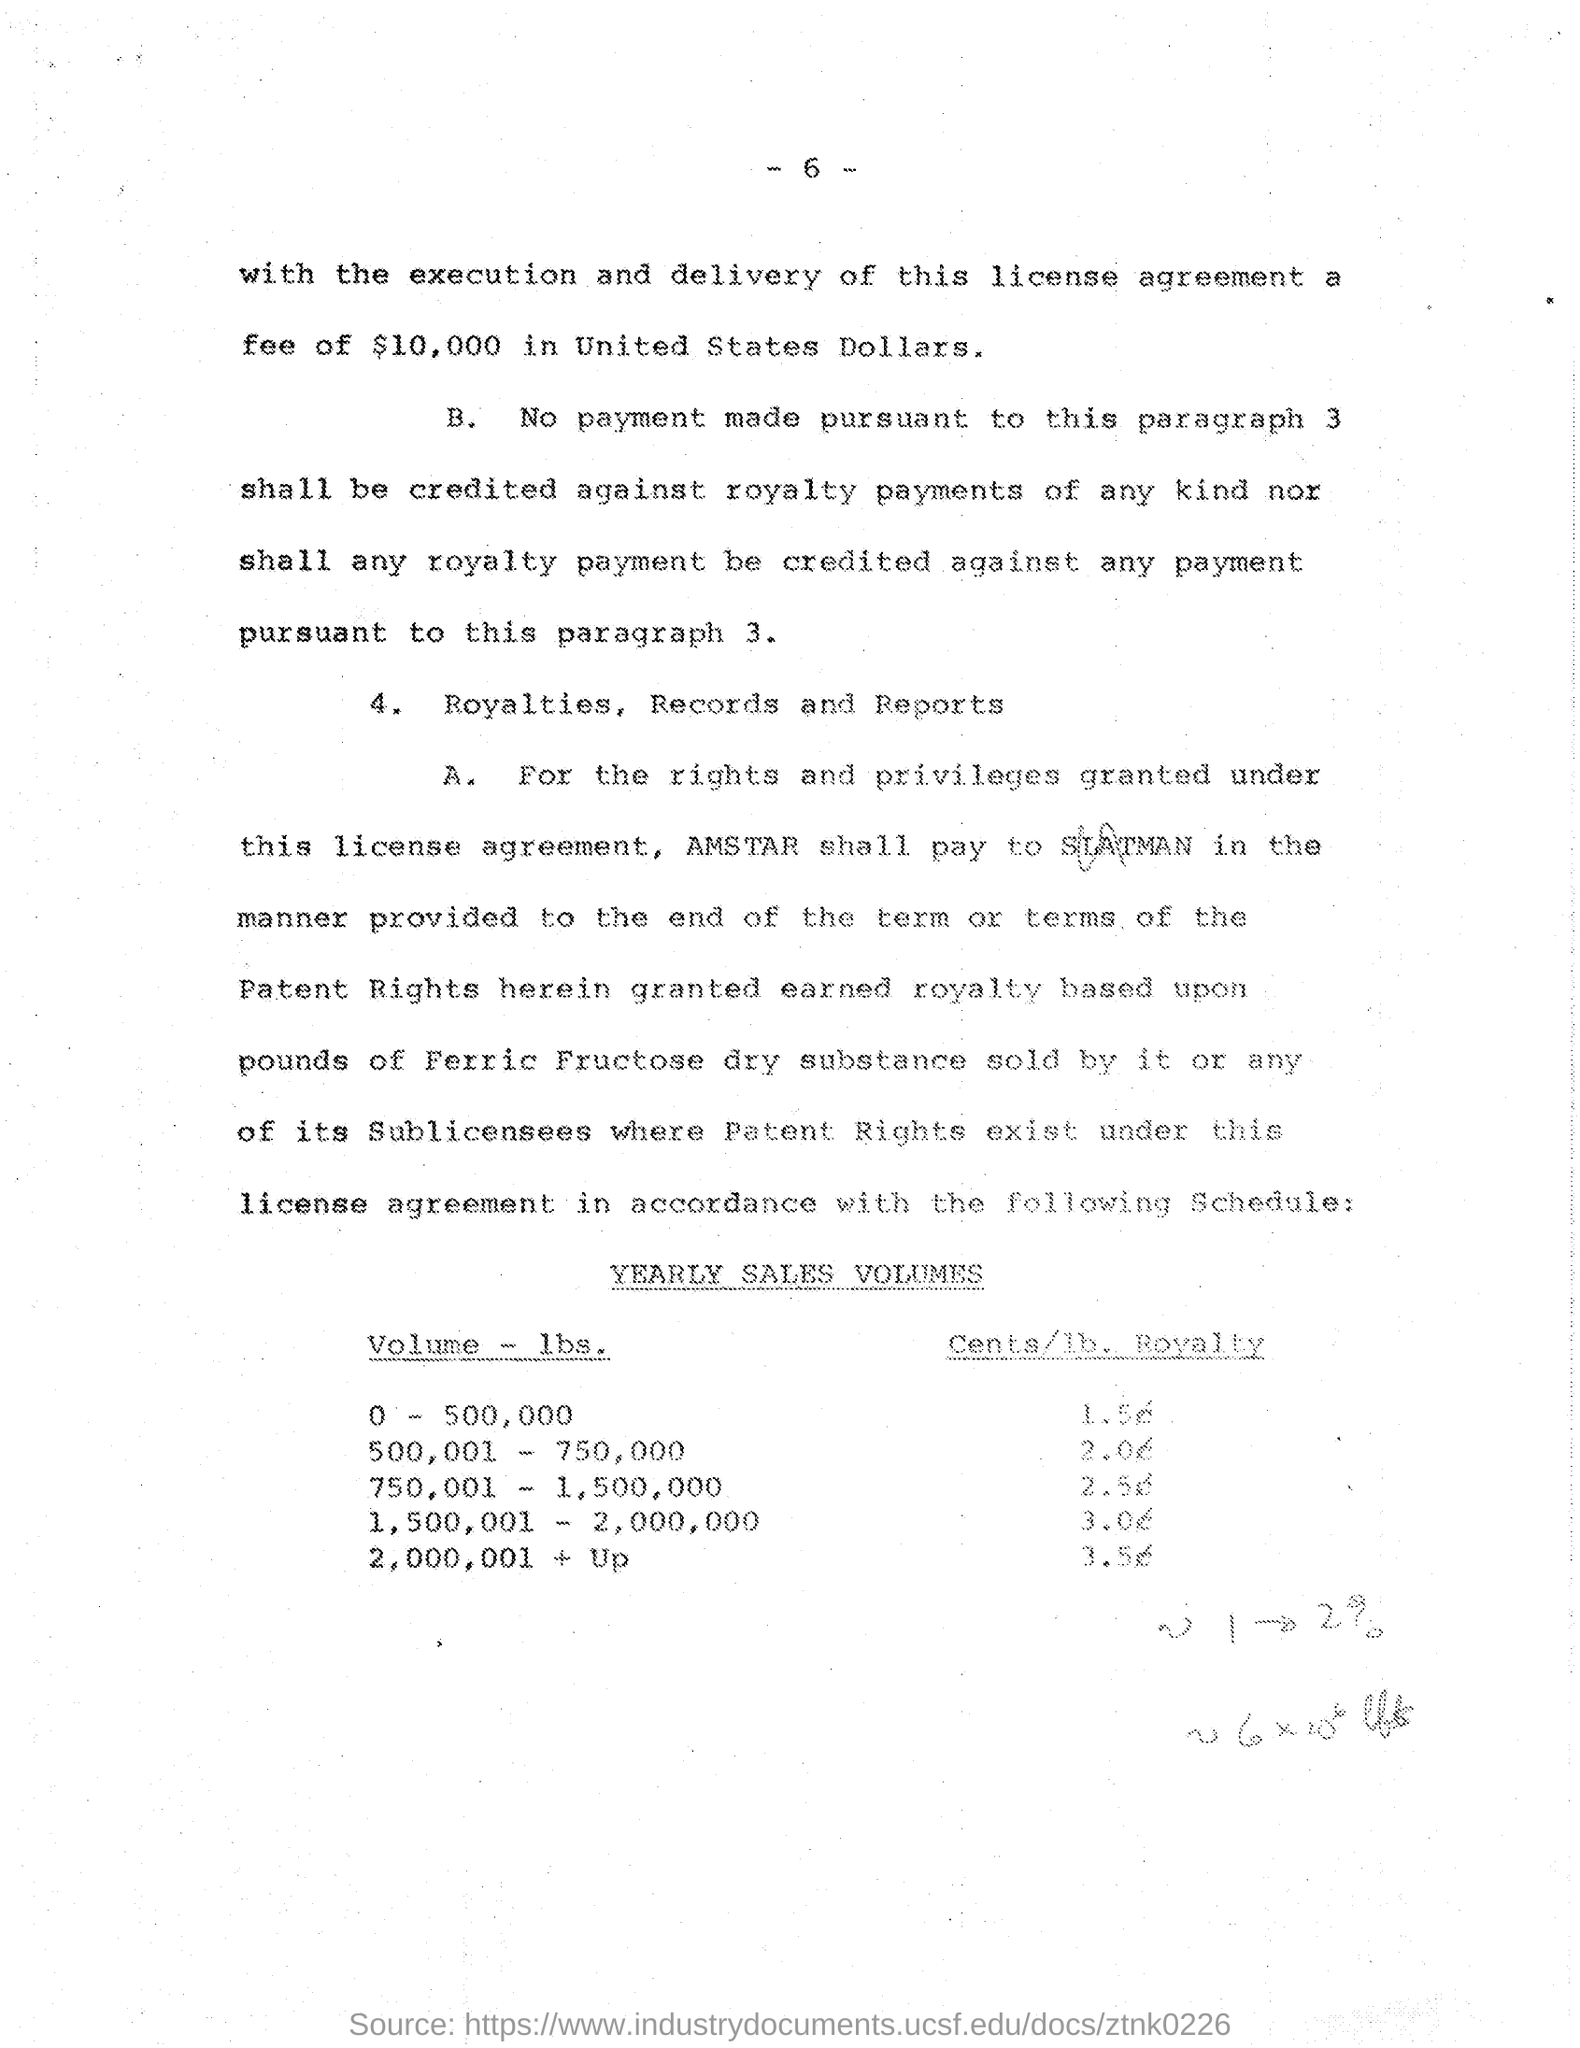Draw attention to some important aspects in this diagram. The amount of Fee is $10,000. 